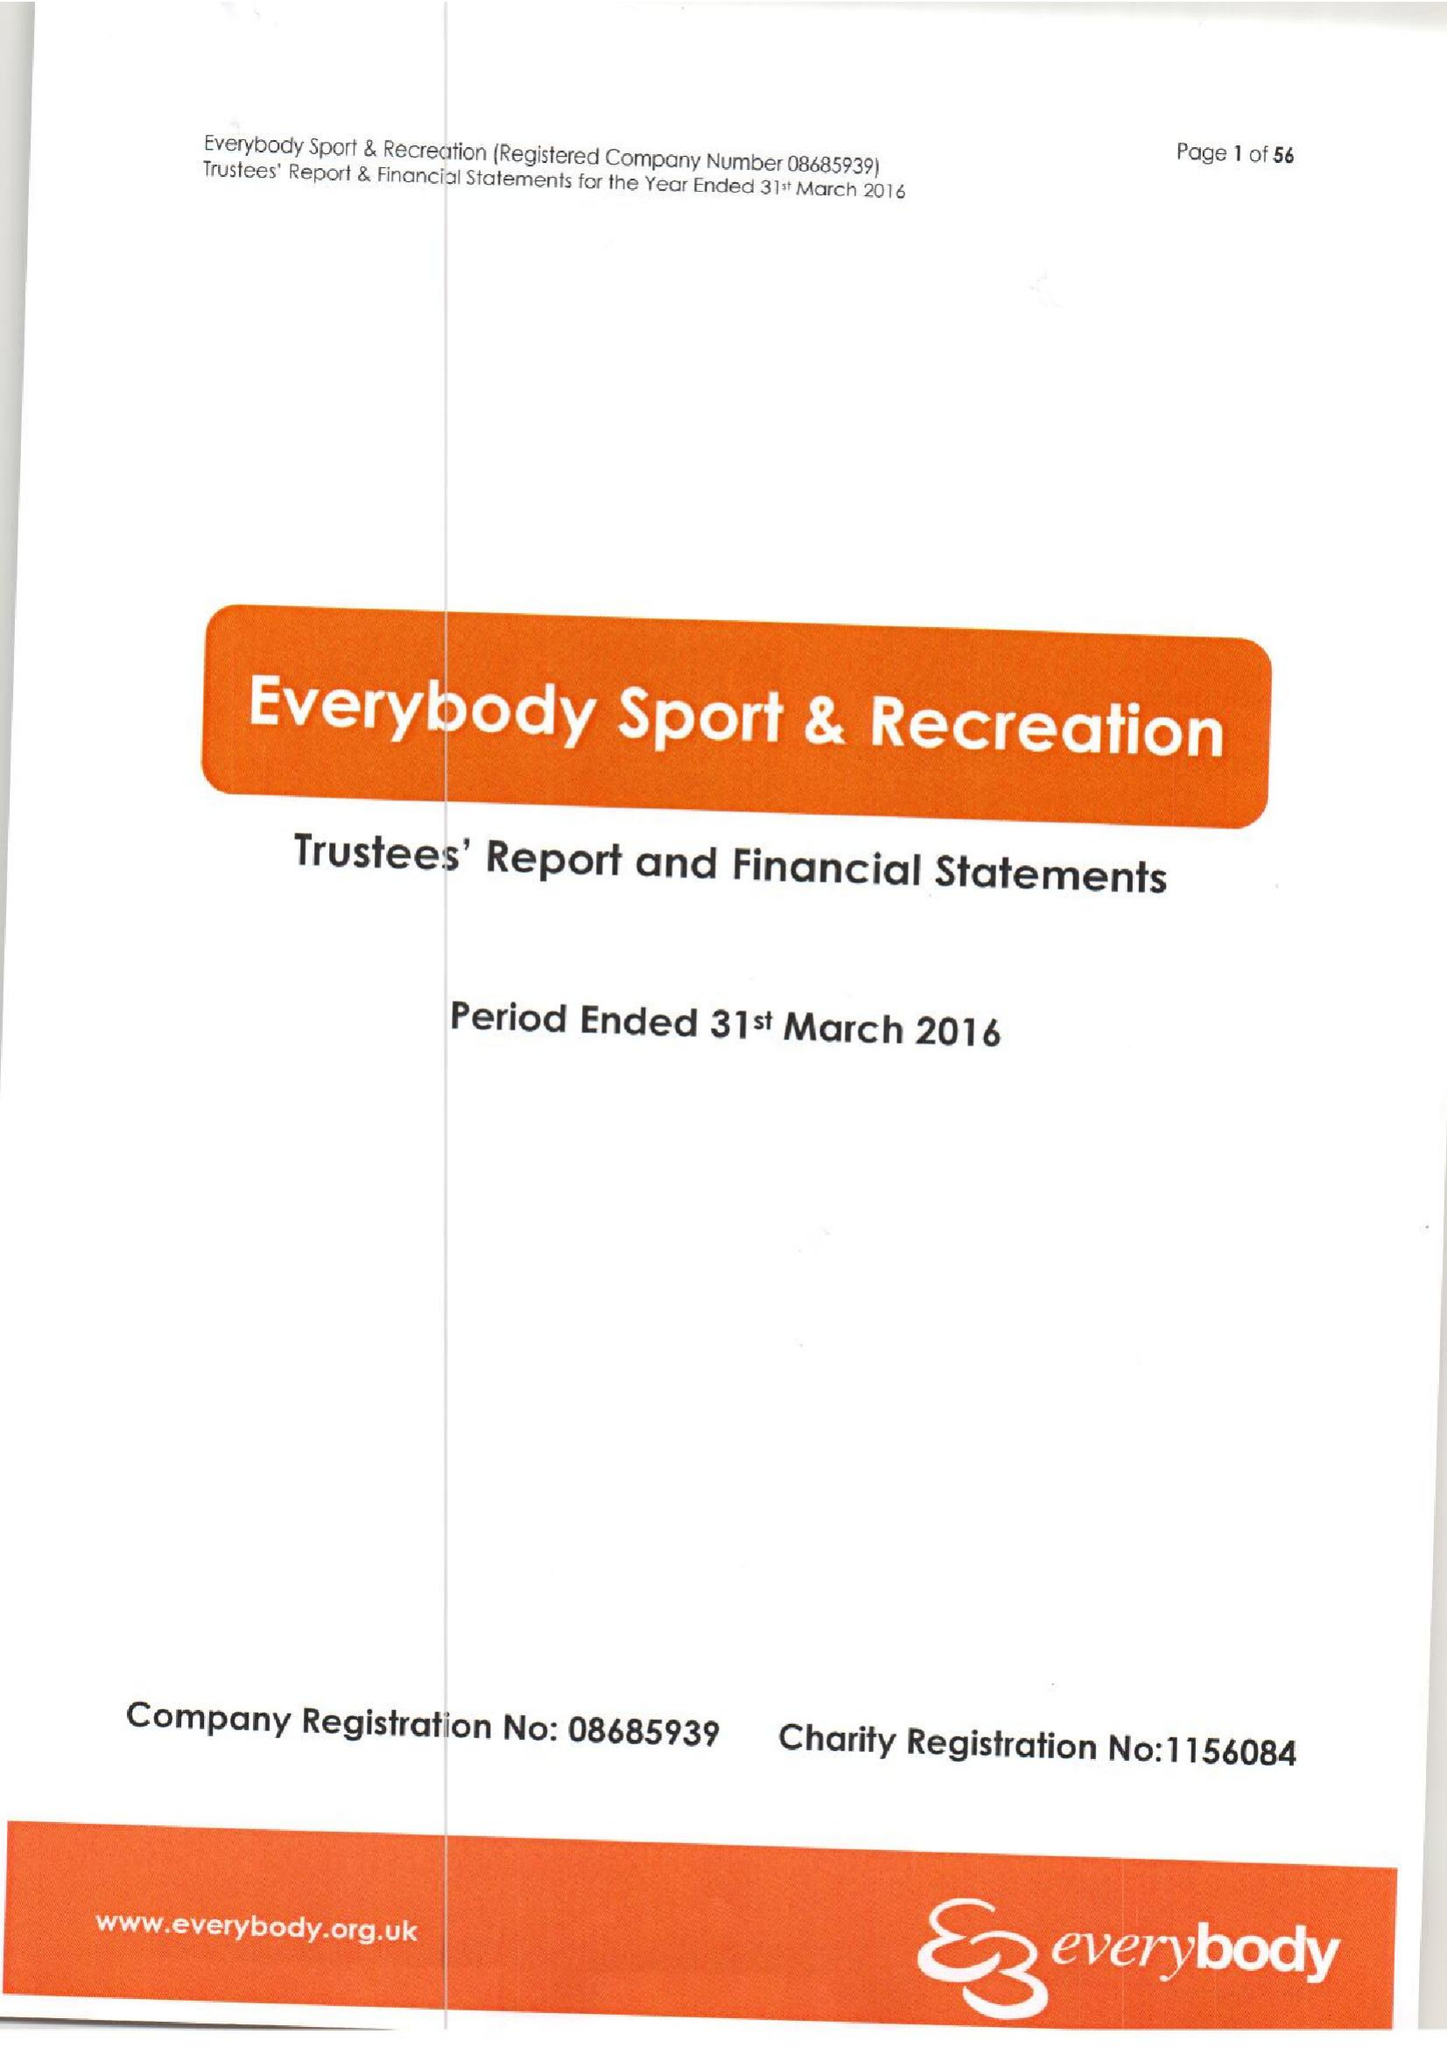What is the value for the address__post_town?
Answer the question using a single word or phrase. CREWE 